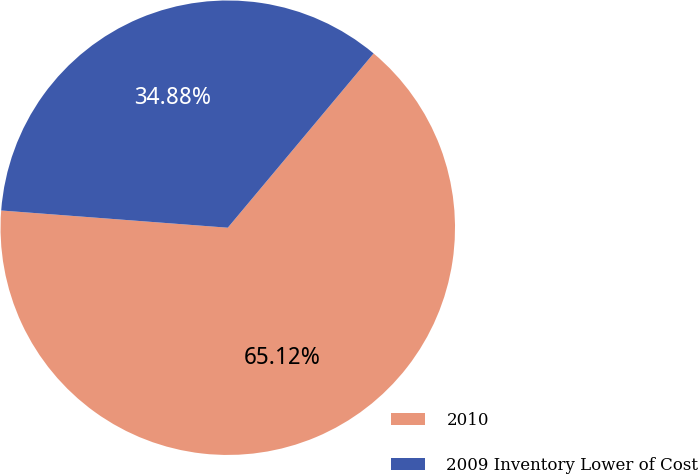Convert chart to OTSL. <chart><loc_0><loc_0><loc_500><loc_500><pie_chart><fcel>2010<fcel>2009 Inventory Lower of Cost<nl><fcel>65.12%<fcel>34.88%<nl></chart> 